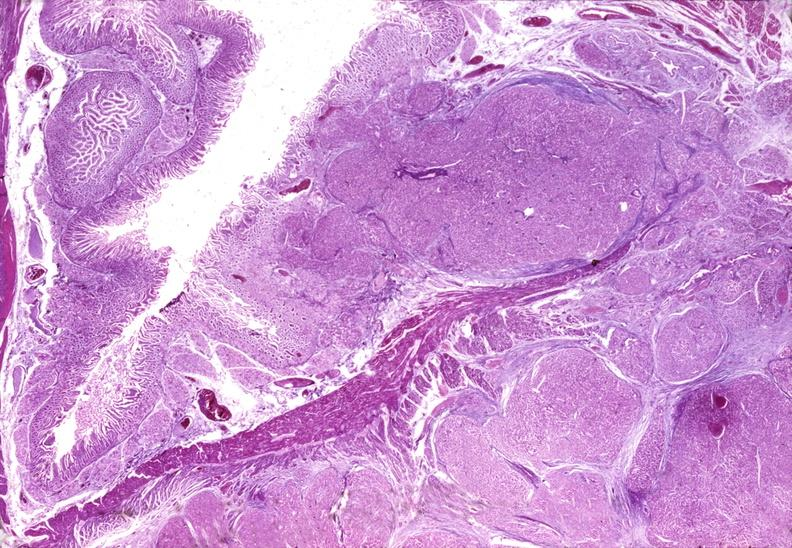what is present?
Answer the question using a single word or phrase. Pancreas 